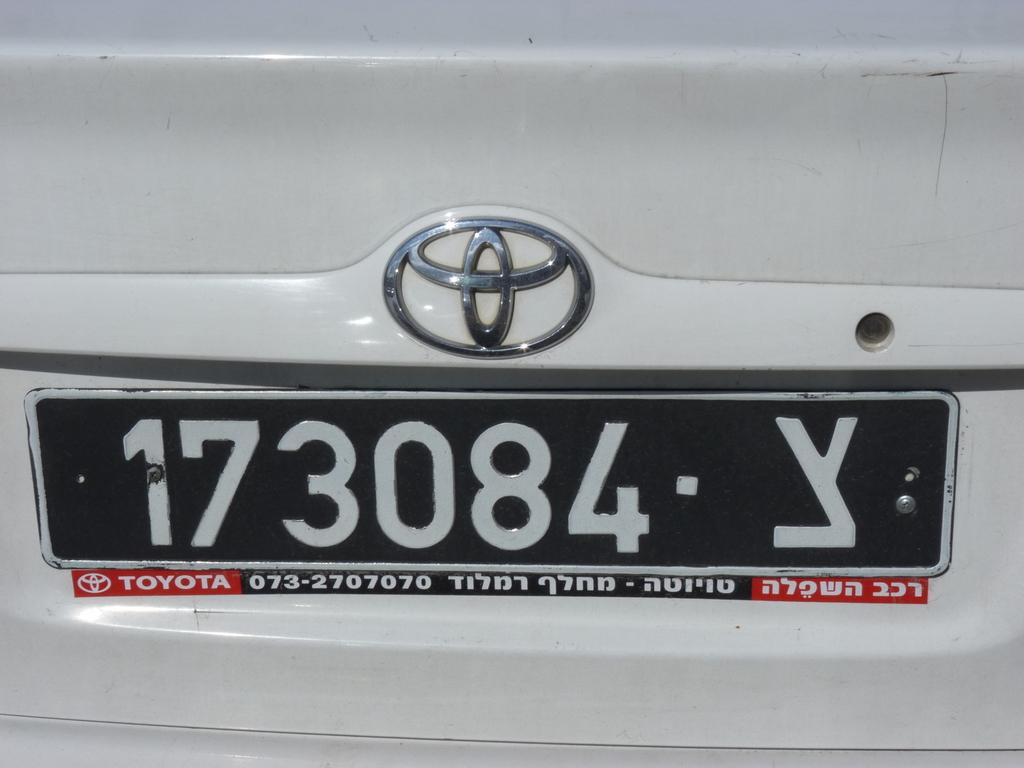What is the license plate number?
Provide a short and direct response. 173084. What brand is the car?
Your answer should be very brief. Toyota. 